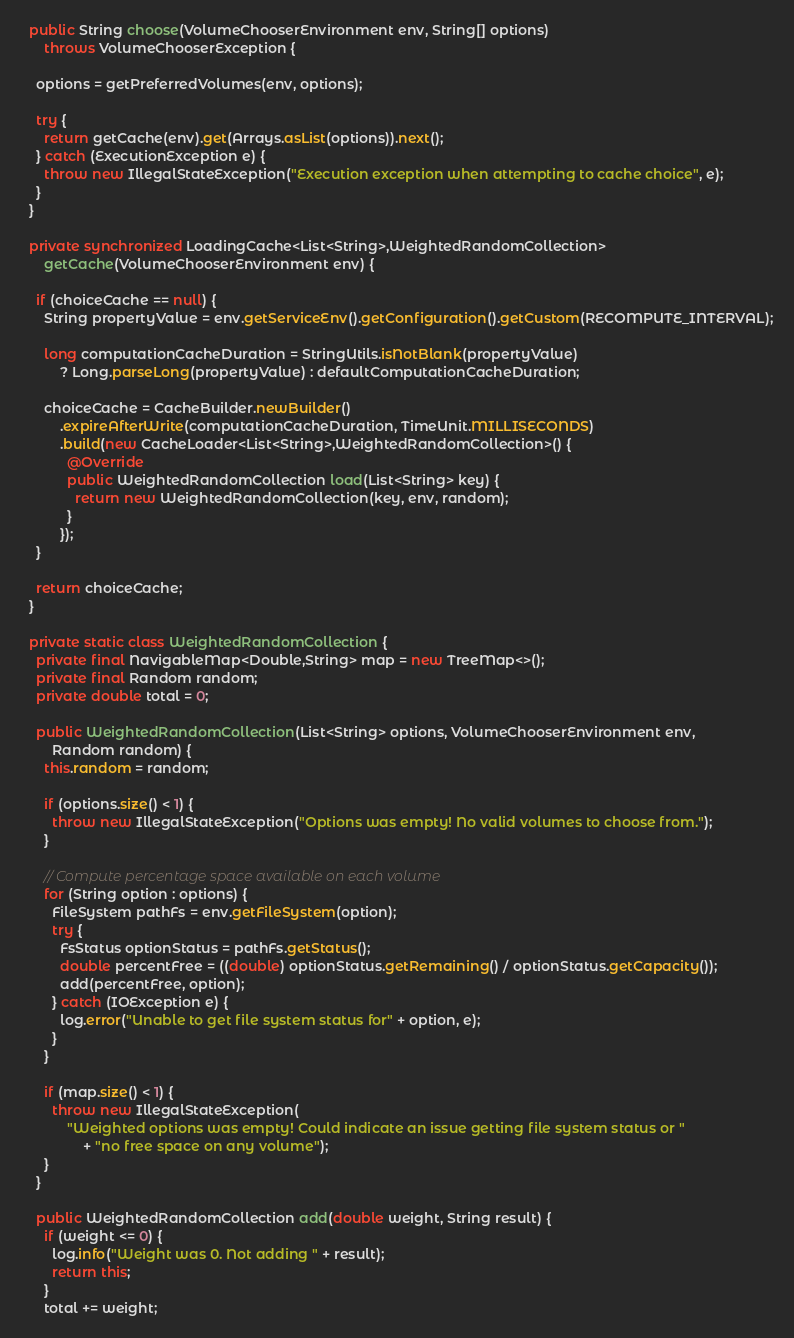<code> <loc_0><loc_0><loc_500><loc_500><_Java_>  public String choose(VolumeChooserEnvironment env, String[] options)
      throws VolumeChooserException {

    options = getPreferredVolumes(env, options);

    try {
      return getCache(env).get(Arrays.asList(options)).next();
    } catch (ExecutionException e) {
      throw new IllegalStateException("Execution exception when attempting to cache choice", e);
    }
  }

  private synchronized LoadingCache<List<String>,WeightedRandomCollection>
      getCache(VolumeChooserEnvironment env) {

    if (choiceCache == null) {
      String propertyValue = env.getServiceEnv().getConfiguration().getCustom(RECOMPUTE_INTERVAL);

      long computationCacheDuration = StringUtils.isNotBlank(propertyValue)
          ? Long.parseLong(propertyValue) : defaultComputationCacheDuration;

      choiceCache = CacheBuilder.newBuilder()
          .expireAfterWrite(computationCacheDuration, TimeUnit.MILLISECONDS)
          .build(new CacheLoader<List<String>,WeightedRandomCollection>() {
            @Override
            public WeightedRandomCollection load(List<String> key) {
              return new WeightedRandomCollection(key, env, random);
            }
          });
    }

    return choiceCache;
  }

  private static class WeightedRandomCollection {
    private final NavigableMap<Double,String> map = new TreeMap<>();
    private final Random random;
    private double total = 0;

    public WeightedRandomCollection(List<String> options, VolumeChooserEnvironment env,
        Random random) {
      this.random = random;

      if (options.size() < 1) {
        throw new IllegalStateException("Options was empty! No valid volumes to choose from.");
      }

      // Compute percentage space available on each volume
      for (String option : options) {
        FileSystem pathFs = env.getFileSystem(option);
        try {
          FsStatus optionStatus = pathFs.getStatus();
          double percentFree = ((double) optionStatus.getRemaining() / optionStatus.getCapacity());
          add(percentFree, option);
        } catch (IOException e) {
          log.error("Unable to get file system status for" + option, e);
        }
      }

      if (map.size() < 1) {
        throw new IllegalStateException(
            "Weighted options was empty! Could indicate an issue getting file system status or "
                + "no free space on any volume");
      }
    }

    public WeightedRandomCollection add(double weight, String result) {
      if (weight <= 0) {
        log.info("Weight was 0. Not adding " + result);
        return this;
      }
      total += weight;</code> 